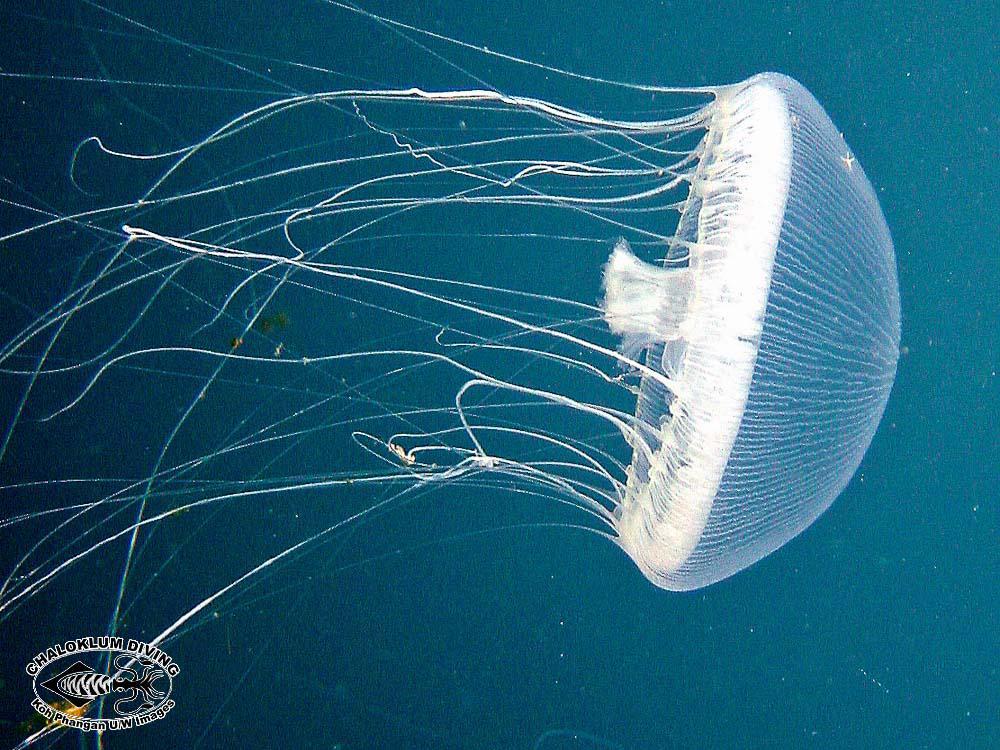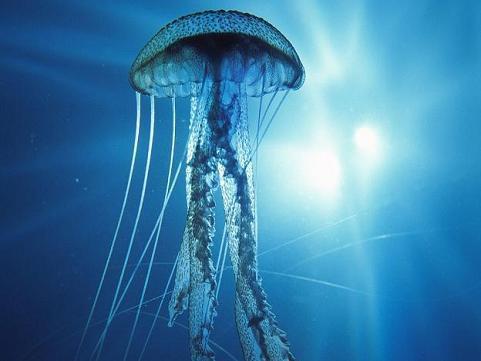The first image is the image on the left, the second image is the image on the right. Examine the images to the left and right. Is the description "There is not less than one scuba diver" accurate? Answer yes or no. No. 